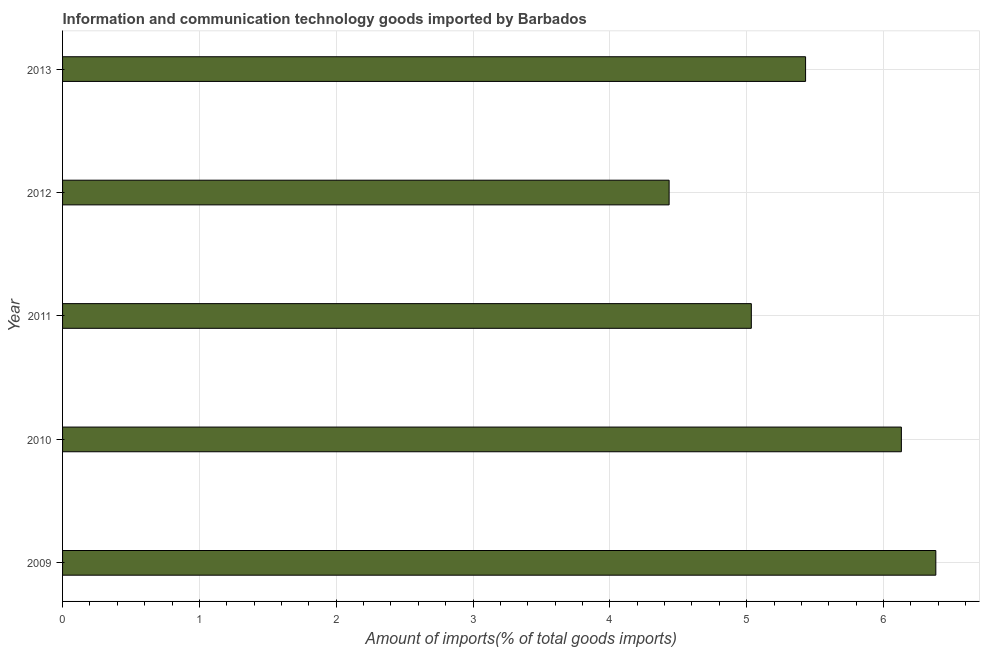Does the graph contain any zero values?
Your response must be concise. No. What is the title of the graph?
Your response must be concise. Information and communication technology goods imported by Barbados. What is the label or title of the X-axis?
Your response must be concise. Amount of imports(% of total goods imports). What is the amount of ict goods imports in 2009?
Ensure brevity in your answer.  6.38. Across all years, what is the maximum amount of ict goods imports?
Offer a very short reply. 6.38. Across all years, what is the minimum amount of ict goods imports?
Your answer should be compact. 4.43. In which year was the amount of ict goods imports minimum?
Your answer should be very brief. 2012. What is the sum of the amount of ict goods imports?
Your response must be concise. 27.41. What is the difference between the amount of ict goods imports in 2009 and 2013?
Ensure brevity in your answer.  0.95. What is the average amount of ict goods imports per year?
Keep it short and to the point. 5.48. What is the median amount of ict goods imports?
Provide a succinct answer. 5.43. In how many years, is the amount of ict goods imports greater than 6 %?
Your response must be concise. 2. What is the ratio of the amount of ict goods imports in 2009 to that in 2012?
Make the answer very short. 1.44. Is the amount of ict goods imports in 2011 less than that in 2013?
Your response must be concise. Yes. Is the difference between the amount of ict goods imports in 2009 and 2012 greater than the difference between any two years?
Ensure brevity in your answer.  Yes. What is the difference between the highest and the second highest amount of ict goods imports?
Give a very brief answer. 0.25. Is the sum of the amount of ict goods imports in 2010 and 2011 greater than the maximum amount of ict goods imports across all years?
Provide a short and direct response. Yes. What is the difference between the highest and the lowest amount of ict goods imports?
Make the answer very short. 1.95. In how many years, is the amount of ict goods imports greater than the average amount of ict goods imports taken over all years?
Offer a terse response. 2. How many years are there in the graph?
Your answer should be very brief. 5. What is the Amount of imports(% of total goods imports) of 2009?
Offer a very short reply. 6.38. What is the Amount of imports(% of total goods imports) of 2010?
Ensure brevity in your answer.  6.13. What is the Amount of imports(% of total goods imports) in 2011?
Your response must be concise. 5.03. What is the Amount of imports(% of total goods imports) of 2012?
Ensure brevity in your answer.  4.43. What is the Amount of imports(% of total goods imports) of 2013?
Give a very brief answer. 5.43. What is the difference between the Amount of imports(% of total goods imports) in 2009 and 2010?
Your response must be concise. 0.25. What is the difference between the Amount of imports(% of total goods imports) in 2009 and 2011?
Offer a very short reply. 1.35. What is the difference between the Amount of imports(% of total goods imports) in 2009 and 2012?
Provide a short and direct response. 1.95. What is the difference between the Amount of imports(% of total goods imports) in 2009 and 2013?
Make the answer very short. 0.95. What is the difference between the Amount of imports(% of total goods imports) in 2010 and 2011?
Offer a very short reply. 1.1. What is the difference between the Amount of imports(% of total goods imports) in 2010 and 2012?
Provide a succinct answer. 1.7. What is the difference between the Amount of imports(% of total goods imports) in 2010 and 2013?
Keep it short and to the point. 0.7. What is the difference between the Amount of imports(% of total goods imports) in 2011 and 2012?
Your answer should be very brief. 0.6. What is the difference between the Amount of imports(% of total goods imports) in 2011 and 2013?
Your answer should be very brief. -0.4. What is the difference between the Amount of imports(% of total goods imports) in 2012 and 2013?
Ensure brevity in your answer.  -1. What is the ratio of the Amount of imports(% of total goods imports) in 2009 to that in 2010?
Ensure brevity in your answer.  1.04. What is the ratio of the Amount of imports(% of total goods imports) in 2009 to that in 2011?
Provide a succinct answer. 1.27. What is the ratio of the Amount of imports(% of total goods imports) in 2009 to that in 2012?
Offer a very short reply. 1.44. What is the ratio of the Amount of imports(% of total goods imports) in 2009 to that in 2013?
Provide a succinct answer. 1.18. What is the ratio of the Amount of imports(% of total goods imports) in 2010 to that in 2011?
Your answer should be very brief. 1.22. What is the ratio of the Amount of imports(% of total goods imports) in 2010 to that in 2012?
Your response must be concise. 1.38. What is the ratio of the Amount of imports(% of total goods imports) in 2010 to that in 2013?
Your response must be concise. 1.13. What is the ratio of the Amount of imports(% of total goods imports) in 2011 to that in 2012?
Offer a terse response. 1.14. What is the ratio of the Amount of imports(% of total goods imports) in 2011 to that in 2013?
Offer a very short reply. 0.93. What is the ratio of the Amount of imports(% of total goods imports) in 2012 to that in 2013?
Ensure brevity in your answer.  0.82. 